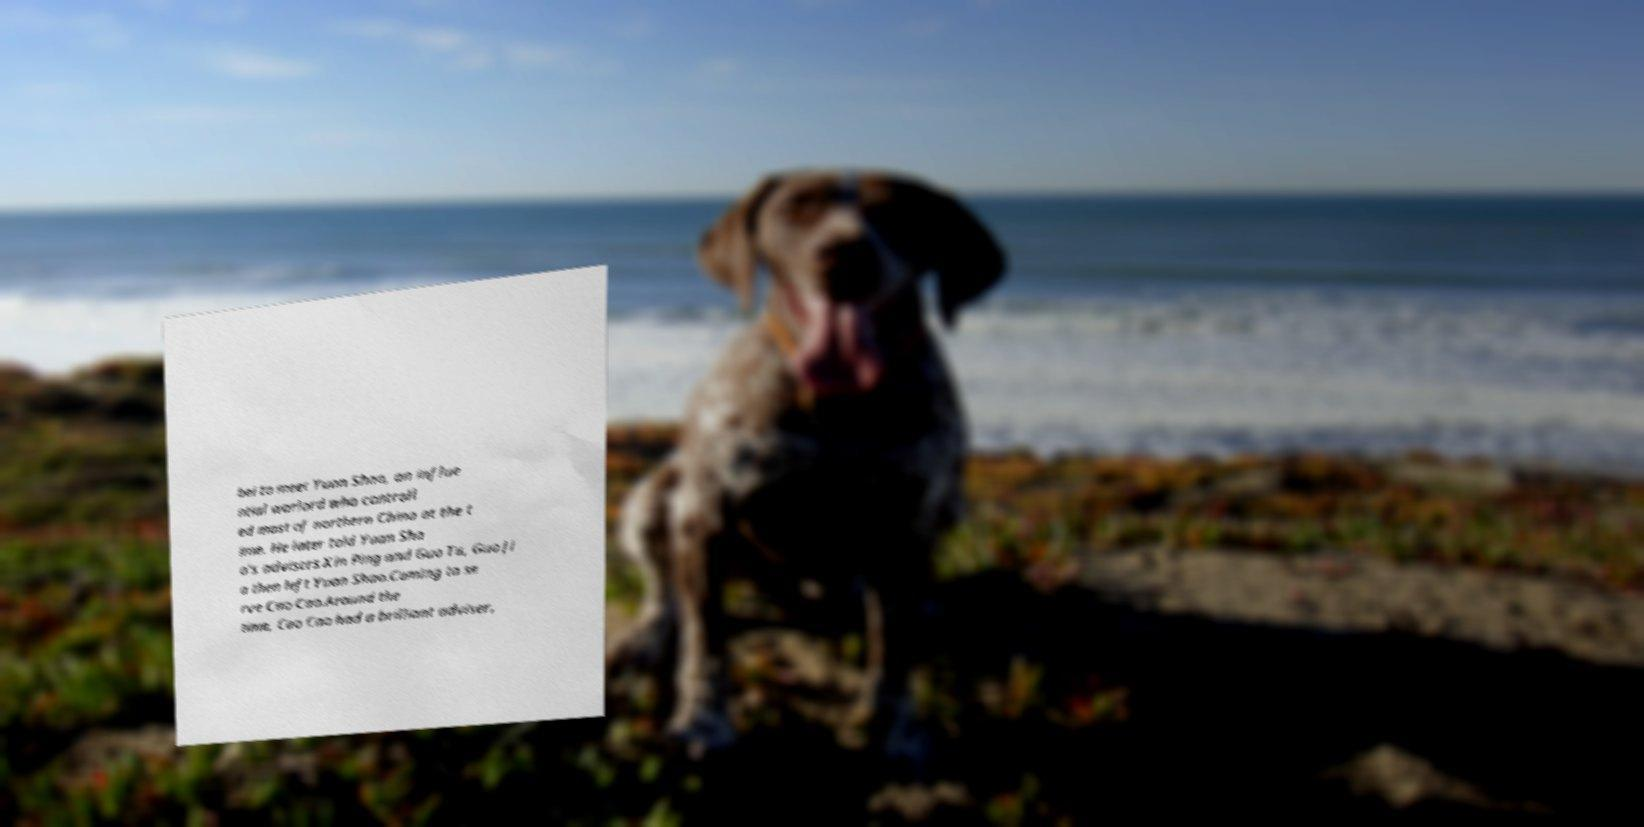Can you read and provide the text displayed in the image?This photo seems to have some interesting text. Can you extract and type it out for me? bei to meet Yuan Shao, an influe ntial warlord who controll ed most of northern China at the t ime. He later told Yuan Sha o's advisers Xin Ping and Guo Tu, Guo Ji a then left Yuan Shao.Coming to se rve Cao Cao.Around the time, Cao Cao had a brilliant adviser, 